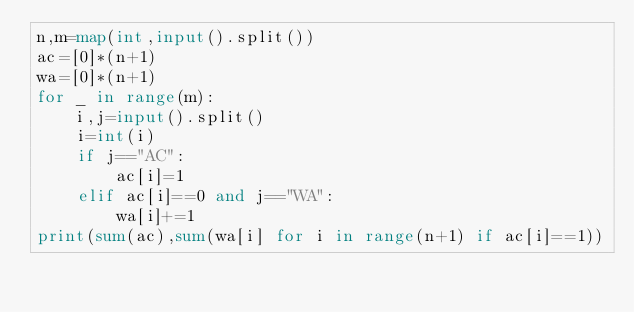Convert code to text. <code><loc_0><loc_0><loc_500><loc_500><_Python_>n,m=map(int,input().split())
ac=[0]*(n+1)
wa=[0]*(n+1)
for _ in range(m):
    i,j=input().split()
    i=int(i)
    if j=="AC":
        ac[i]=1
    elif ac[i]==0 and j=="WA":
        wa[i]+=1
print(sum(ac),sum(wa[i] for i in range(n+1) if ac[i]==1))  </code> 